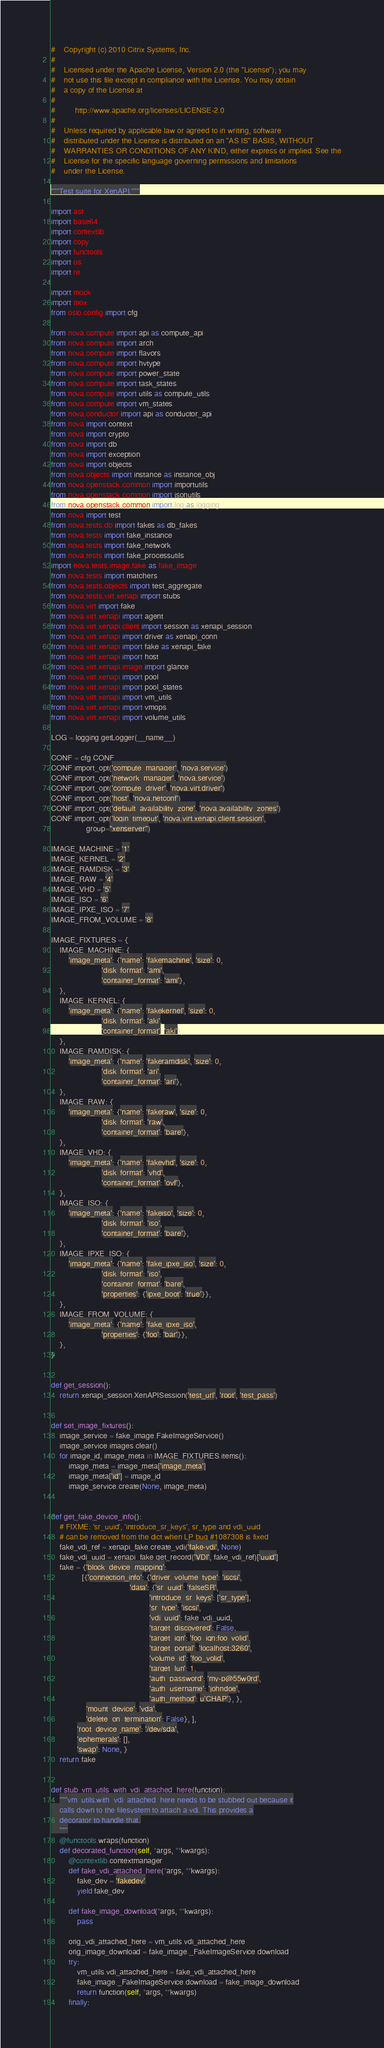<code> <loc_0><loc_0><loc_500><loc_500><_Python_>#    Copyright (c) 2010 Citrix Systems, Inc.
#
#    Licensed under the Apache License, Version 2.0 (the "License"); you may
#    not use this file except in compliance with the License. You may obtain
#    a copy of the License at
#
#         http://www.apache.org/licenses/LICENSE-2.0
#
#    Unless required by applicable law or agreed to in writing, software
#    distributed under the License is distributed on an "AS IS" BASIS, WITHOUT
#    WARRANTIES OR CONDITIONS OF ANY KIND, either express or implied. See the
#    License for the specific language governing permissions and limitations
#    under the License.

"""Test suite for XenAPI."""

import ast
import base64
import contextlib
import copy
import functools
import os
import re

import mock
import mox
from oslo.config import cfg

from nova.compute import api as compute_api
from nova.compute import arch
from nova.compute import flavors
from nova.compute import hvtype
from nova.compute import power_state
from nova.compute import task_states
from nova.compute import utils as compute_utils
from nova.compute import vm_states
from nova.conductor import api as conductor_api
from nova import context
from nova import crypto
from nova import db
from nova import exception
from nova import objects
from nova.objects import instance as instance_obj
from nova.openstack.common import importutils
from nova.openstack.common import jsonutils
from nova.openstack.common import log as logging
from nova import test
from nova.tests.db import fakes as db_fakes
from nova.tests import fake_instance
from nova.tests import fake_network
from nova.tests import fake_processutils
import nova.tests.image.fake as fake_image
from nova.tests import matchers
from nova.tests.objects import test_aggregate
from nova.tests.virt.xenapi import stubs
from nova.virt import fake
from nova.virt.xenapi import agent
from nova.virt.xenapi.client import session as xenapi_session
from nova.virt.xenapi import driver as xenapi_conn
from nova.virt.xenapi import fake as xenapi_fake
from nova.virt.xenapi import host
from nova.virt.xenapi.image import glance
from nova.virt.xenapi import pool
from nova.virt.xenapi import pool_states
from nova.virt.xenapi import vm_utils
from nova.virt.xenapi import vmops
from nova.virt.xenapi import volume_utils

LOG = logging.getLogger(__name__)

CONF = cfg.CONF
CONF.import_opt('compute_manager', 'nova.service')
CONF.import_opt('network_manager', 'nova.service')
CONF.import_opt('compute_driver', 'nova.virt.driver')
CONF.import_opt('host', 'nova.netconf')
CONF.import_opt('default_availability_zone', 'nova.availability_zones')
CONF.import_opt('login_timeout', 'nova.virt.xenapi.client.session',
                group="xenserver")

IMAGE_MACHINE = '1'
IMAGE_KERNEL = '2'
IMAGE_RAMDISK = '3'
IMAGE_RAW = '4'
IMAGE_VHD = '5'
IMAGE_ISO = '6'
IMAGE_IPXE_ISO = '7'
IMAGE_FROM_VOLUME = '8'

IMAGE_FIXTURES = {
    IMAGE_MACHINE: {
        'image_meta': {'name': 'fakemachine', 'size': 0,
                       'disk_format': 'ami',
                       'container_format': 'ami'},
    },
    IMAGE_KERNEL: {
        'image_meta': {'name': 'fakekernel', 'size': 0,
                       'disk_format': 'aki',
                       'container_format': 'aki'},
    },
    IMAGE_RAMDISK: {
        'image_meta': {'name': 'fakeramdisk', 'size': 0,
                       'disk_format': 'ari',
                       'container_format': 'ari'},
    },
    IMAGE_RAW: {
        'image_meta': {'name': 'fakeraw', 'size': 0,
                       'disk_format': 'raw',
                       'container_format': 'bare'},
    },
    IMAGE_VHD: {
        'image_meta': {'name': 'fakevhd', 'size': 0,
                       'disk_format': 'vhd',
                       'container_format': 'ovf'},
    },
    IMAGE_ISO: {
        'image_meta': {'name': 'fakeiso', 'size': 0,
                       'disk_format': 'iso',
                       'container_format': 'bare'},
    },
    IMAGE_IPXE_ISO: {
        'image_meta': {'name': 'fake_ipxe_iso', 'size': 0,
                       'disk_format': 'iso',
                       'container_format': 'bare',
                       'properties': {'ipxe_boot': 'true'}},
    },
    IMAGE_FROM_VOLUME: {
        'image_meta': {'name': 'fake_ipxe_iso',
                       'properties': {'foo': 'bar'}},
    },
}


def get_session():
    return xenapi_session.XenAPISession('test_url', 'root', 'test_pass')


def set_image_fixtures():
    image_service = fake_image.FakeImageService()
    image_service.images.clear()
    for image_id, image_meta in IMAGE_FIXTURES.items():
        image_meta = image_meta['image_meta']
        image_meta['id'] = image_id
        image_service.create(None, image_meta)


def get_fake_device_info():
    # FIXME: 'sr_uuid', 'introduce_sr_keys', sr_type and vdi_uuid
    # can be removed from the dict when LP bug #1087308 is fixed
    fake_vdi_ref = xenapi_fake.create_vdi('fake-vdi', None)
    fake_vdi_uuid = xenapi_fake.get_record('VDI', fake_vdi_ref)['uuid']
    fake = {'block_device_mapping':
              [{'connection_info': {'driver_volume_type': 'iscsi',
                                    'data': {'sr_uuid': 'falseSR',
                                             'introduce_sr_keys': ['sr_type'],
                                             'sr_type': 'iscsi',
                                             'vdi_uuid': fake_vdi_uuid,
                                             'target_discovered': False,
                                             'target_iqn': 'foo_iqn:foo_volid',
                                             'target_portal': 'localhost:3260',
                                             'volume_id': 'foo_volid',
                                             'target_lun': 1,
                                             'auth_password': 'my-p@55w0rd',
                                             'auth_username': 'johndoe',
                                             'auth_method': u'CHAP'}, },
                'mount_device': 'vda',
                'delete_on_termination': False}, ],
            'root_device_name': '/dev/sda',
            'ephemerals': [],
            'swap': None, }
    return fake


def stub_vm_utils_with_vdi_attached_here(function):
    """vm_utils.with_vdi_attached_here needs to be stubbed out because it
    calls down to the filesystem to attach a vdi. This provides a
    decorator to handle that.
    """
    @functools.wraps(function)
    def decorated_function(self, *args, **kwargs):
        @contextlib.contextmanager
        def fake_vdi_attached_here(*args, **kwargs):
            fake_dev = 'fakedev'
            yield fake_dev

        def fake_image_download(*args, **kwargs):
            pass

        orig_vdi_attached_here = vm_utils.vdi_attached_here
        orig_image_download = fake_image._FakeImageService.download
        try:
            vm_utils.vdi_attached_here = fake_vdi_attached_here
            fake_image._FakeImageService.download = fake_image_download
            return function(self, *args, **kwargs)
        finally:</code> 